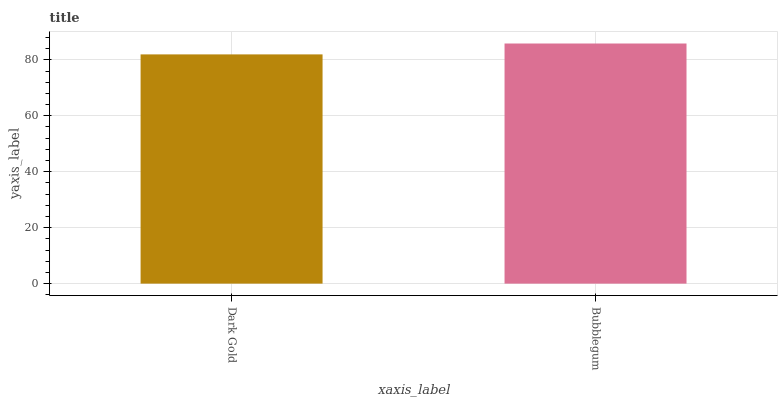Is Dark Gold the minimum?
Answer yes or no. Yes. Is Bubblegum the maximum?
Answer yes or no. Yes. Is Bubblegum the minimum?
Answer yes or no. No. Is Bubblegum greater than Dark Gold?
Answer yes or no. Yes. Is Dark Gold less than Bubblegum?
Answer yes or no. Yes. Is Dark Gold greater than Bubblegum?
Answer yes or no. No. Is Bubblegum less than Dark Gold?
Answer yes or no. No. Is Bubblegum the high median?
Answer yes or no. Yes. Is Dark Gold the low median?
Answer yes or no. Yes. Is Dark Gold the high median?
Answer yes or no. No. Is Bubblegum the low median?
Answer yes or no. No. 